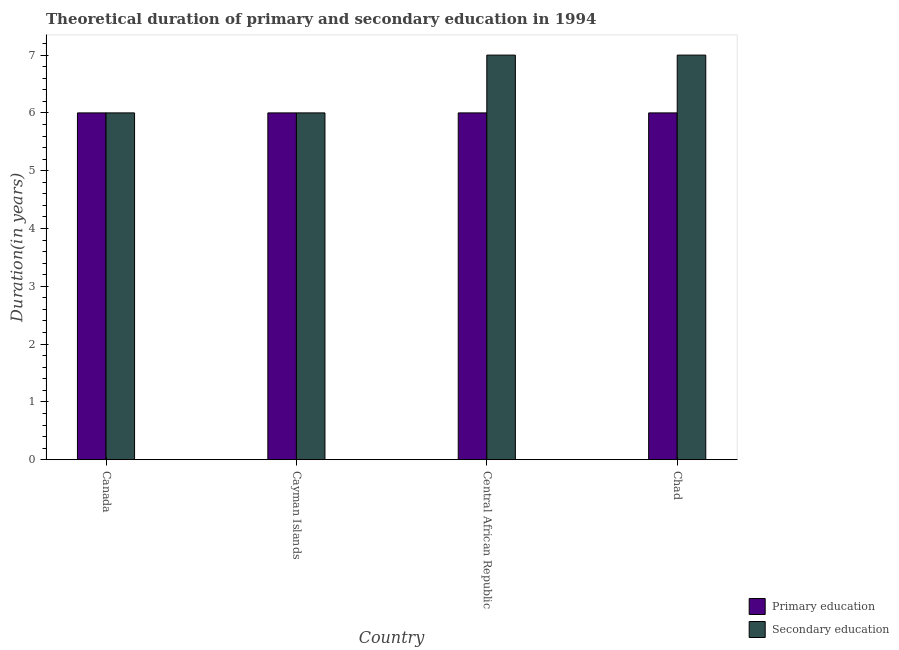How many groups of bars are there?
Ensure brevity in your answer.  4. Are the number of bars on each tick of the X-axis equal?
Keep it short and to the point. Yes. How many bars are there on the 1st tick from the right?
Your response must be concise. 2. What is the label of the 4th group of bars from the left?
Ensure brevity in your answer.  Chad. In how many cases, is the number of bars for a given country not equal to the number of legend labels?
Ensure brevity in your answer.  0. What is the duration of secondary education in Central African Republic?
Provide a short and direct response. 7. What is the total duration of primary education in the graph?
Make the answer very short. 24. What is the difference between the duration of secondary education in Cayman Islands and that in Central African Republic?
Provide a succinct answer. -1. What is the difference between the duration of primary education and duration of secondary education in Chad?
Ensure brevity in your answer.  -1. What is the difference between the highest and the second highest duration of primary education?
Give a very brief answer. 0. What is the difference between the highest and the lowest duration of primary education?
Give a very brief answer. 0. Is the sum of the duration of primary education in Cayman Islands and Chad greater than the maximum duration of secondary education across all countries?
Make the answer very short. Yes. What does the 2nd bar from the left in Cayman Islands represents?
Ensure brevity in your answer.  Secondary education. What does the 1st bar from the right in Chad represents?
Your answer should be very brief. Secondary education. Are all the bars in the graph horizontal?
Offer a very short reply. No. How many countries are there in the graph?
Make the answer very short. 4. Are the values on the major ticks of Y-axis written in scientific E-notation?
Your answer should be very brief. No. Does the graph contain grids?
Offer a terse response. No. How many legend labels are there?
Offer a very short reply. 2. How are the legend labels stacked?
Give a very brief answer. Vertical. What is the title of the graph?
Provide a short and direct response. Theoretical duration of primary and secondary education in 1994. Does "Age 65(male)" appear as one of the legend labels in the graph?
Your answer should be compact. No. What is the label or title of the Y-axis?
Provide a succinct answer. Duration(in years). What is the Duration(in years) of Primary education in Canada?
Your response must be concise. 6. What is the Duration(in years) of Primary education in Cayman Islands?
Your answer should be compact. 6. What is the Duration(in years) in Primary education in Central African Republic?
Make the answer very short. 6. What is the Duration(in years) in Secondary education in Central African Republic?
Give a very brief answer. 7. Across all countries, what is the maximum Duration(in years) in Primary education?
Your answer should be very brief. 6. Across all countries, what is the minimum Duration(in years) in Primary education?
Provide a succinct answer. 6. Across all countries, what is the minimum Duration(in years) of Secondary education?
Your response must be concise. 6. What is the difference between the Duration(in years) in Primary education in Canada and that in Cayman Islands?
Give a very brief answer. 0. What is the difference between the Duration(in years) of Secondary education in Canada and that in Cayman Islands?
Offer a terse response. 0. What is the difference between the Duration(in years) in Primary education in Canada and that in Chad?
Your answer should be very brief. 0. What is the difference between the Duration(in years) of Primary education in Cayman Islands and that in Central African Republic?
Make the answer very short. 0. What is the difference between the Duration(in years) of Primary education in Cayman Islands and that in Chad?
Keep it short and to the point. 0. What is the difference between the Duration(in years) in Secondary education in Cayman Islands and that in Chad?
Ensure brevity in your answer.  -1. What is the difference between the Duration(in years) of Primary education in Central African Republic and that in Chad?
Make the answer very short. 0. What is the difference between the Duration(in years) of Secondary education in Central African Republic and that in Chad?
Give a very brief answer. 0. What is the difference between the Duration(in years) in Primary education in Canada and the Duration(in years) in Secondary education in Cayman Islands?
Provide a short and direct response. 0. What is the difference between the Duration(in years) of Primary education in Cayman Islands and the Duration(in years) of Secondary education in Central African Republic?
Your answer should be compact. -1. What is the difference between the Duration(in years) in Primary education and Duration(in years) in Secondary education in Canada?
Keep it short and to the point. 0. What is the difference between the Duration(in years) in Primary education and Duration(in years) in Secondary education in Cayman Islands?
Provide a short and direct response. 0. What is the ratio of the Duration(in years) in Primary education in Canada to that in Cayman Islands?
Make the answer very short. 1. What is the ratio of the Duration(in years) of Primary education in Canada to that in Chad?
Your answer should be very brief. 1. What is the ratio of the Duration(in years) in Secondary education in Canada to that in Chad?
Offer a very short reply. 0.86. What is the ratio of the Duration(in years) of Secondary education in Cayman Islands to that in Central African Republic?
Ensure brevity in your answer.  0.86. What is the ratio of the Duration(in years) of Secondary education in Cayman Islands to that in Chad?
Offer a very short reply. 0.86. What is the difference between the highest and the lowest Duration(in years) in Primary education?
Your answer should be compact. 0. What is the difference between the highest and the lowest Duration(in years) of Secondary education?
Offer a very short reply. 1. 